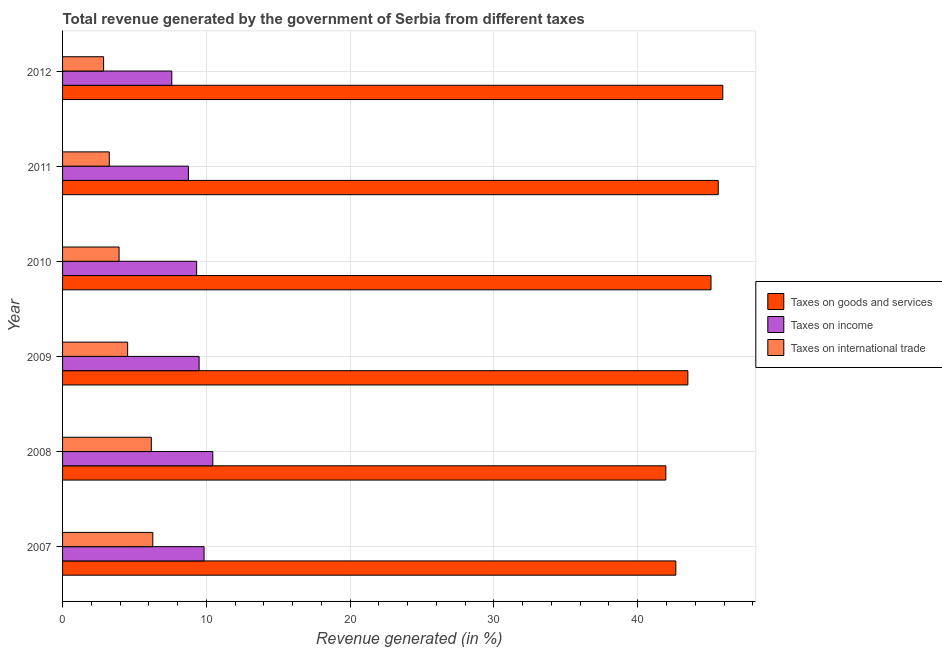How many different coloured bars are there?
Your answer should be very brief. 3. Are the number of bars per tick equal to the number of legend labels?
Offer a terse response. Yes. Are the number of bars on each tick of the Y-axis equal?
Your response must be concise. Yes. How many bars are there on the 2nd tick from the top?
Provide a succinct answer. 3. What is the label of the 3rd group of bars from the top?
Offer a very short reply. 2010. In how many cases, is the number of bars for a given year not equal to the number of legend labels?
Give a very brief answer. 0. What is the percentage of revenue generated by tax on international trade in 2011?
Your answer should be very brief. 3.25. Across all years, what is the maximum percentage of revenue generated by taxes on income?
Your response must be concise. 10.45. Across all years, what is the minimum percentage of revenue generated by taxes on income?
Offer a terse response. 7.6. What is the total percentage of revenue generated by taxes on goods and services in the graph?
Ensure brevity in your answer.  264.69. What is the difference between the percentage of revenue generated by tax on international trade in 2009 and that in 2012?
Give a very brief answer. 1.67. What is the difference between the percentage of revenue generated by tax on international trade in 2007 and the percentage of revenue generated by taxes on goods and services in 2008?
Make the answer very short. -35.68. What is the average percentage of revenue generated by tax on international trade per year?
Make the answer very short. 4.5. In the year 2011, what is the difference between the percentage of revenue generated by taxes on income and percentage of revenue generated by taxes on goods and services?
Make the answer very short. -36.85. In how many years, is the percentage of revenue generated by taxes on income greater than 18 %?
Your response must be concise. 0. What is the ratio of the percentage of revenue generated by taxes on income in 2011 to that in 2012?
Give a very brief answer. 1.15. What is the difference between the highest and the second highest percentage of revenue generated by tax on international trade?
Provide a succinct answer. 0.1. What is the difference between the highest and the lowest percentage of revenue generated by taxes on goods and services?
Your answer should be compact. 3.96. In how many years, is the percentage of revenue generated by taxes on goods and services greater than the average percentage of revenue generated by taxes on goods and services taken over all years?
Your answer should be compact. 3. What does the 3rd bar from the top in 2008 represents?
Your answer should be very brief. Taxes on goods and services. What does the 3rd bar from the bottom in 2008 represents?
Offer a terse response. Taxes on international trade. Are all the bars in the graph horizontal?
Give a very brief answer. Yes. How many years are there in the graph?
Offer a very short reply. 6. Does the graph contain grids?
Offer a terse response. Yes. Where does the legend appear in the graph?
Provide a short and direct response. Center right. How many legend labels are there?
Give a very brief answer. 3. How are the legend labels stacked?
Give a very brief answer. Vertical. What is the title of the graph?
Offer a very short reply. Total revenue generated by the government of Serbia from different taxes. Does "Nuclear sources" appear as one of the legend labels in the graph?
Ensure brevity in your answer.  No. What is the label or title of the X-axis?
Make the answer very short. Revenue generated (in %). What is the label or title of the Y-axis?
Your answer should be compact. Year. What is the Revenue generated (in %) of Taxes on goods and services in 2007?
Your answer should be very brief. 42.65. What is the Revenue generated (in %) in Taxes on income in 2007?
Offer a terse response. 9.84. What is the Revenue generated (in %) of Taxes on international trade in 2007?
Offer a terse response. 6.28. What is the Revenue generated (in %) in Taxes on goods and services in 2008?
Offer a very short reply. 41.95. What is the Revenue generated (in %) in Taxes on income in 2008?
Your answer should be very brief. 10.45. What is the Revenue generated (in %) of Taxes on international trade in 2008?
Make the answer very short. 6.17. What is the Revenue generated (in %) in Taxes on goods and services in 2009?
Your answer should be compact. 43.49. What is the Revenue generated (in %) of Taxes on income in 2009?
Provide a short and direct response. 9.5. What is the Revenue generated (in %) in Taxes on international trade in 2009?
Your response must be concise. 4.53. What is the Revenue generated (in %) of Taxes on goods and services in 2010?
Offer a very short reply. 45.09. What is the Revenue generated (in %) of Taxes on income in 2010?
Provide a short and direct response. 9.32. What is the Revenue generated (in %) of Taxes on international trade in 2010?
Your response must be concise. 3.93. What is the Revenue generated (in %) in Taxes on goods and services in 2011?
Provide a short and direct response. 45.6. What is the Revenue generated (in %) in Taxes on income in 2011?
Make the answer very short. 8.75. What is the Revenue generated (in %) of Taxes on international trade in 2011?
Your answer should be very brief. 3.25. What is the Revenue generated (in %) in Taxes on goods and services in 2012?
Ensure brevity in your answer.  45.91. What is the Revenue generated (in %) in Taxes on income in 2012?
Your response must be concise. 7.6. What is the Revenue generated (in %) in Taxes on international trade in 2012?
Offer a terse response. 2.85. Across all years, what is the maximum Revenue generated (in %) of Taxes on goods and services?
Offer a very short reply. 45.91. Across all years, what is the maximum Revenue generated (in %) of Taxes on income?
Provide a short and direct response. 10.45. Across all years, what is the maximum Revenue generated (in %) of Taxes on international trade?
Your answer should be very brief. 6.28. Across all years, what is the minimum Revenue generated (in %) in Taxes on goods and services?
Your response must be concise. 41.95. Across all years, what is the minimum Revenue generated (in %) in Taxes on income?
Offer a terse response. 7.6. Across all years, what is the minimum Revenue generated (in %) in Taxes on international trade?
Offer a terse response. 2.85. What is the total Revenue generated (in %) in Taxes on goods and services in the graph?
Provide a succinct answer. 264.69. What is the total Revenue generated (in %) of Taxes on income in the graph?
Offer a very short reply. 55.46. What is the total Revenue generated (in %) of Taxes on international trade in the graph?
Offer a terse response. 27.01. What is the difference between the Revenue generated (in %) of Taxes on goods and services in 2007 and that in 2008?
Your response must be concise. 0.69. What is the difference between the Revenue generated (in %) of Taxes on income in 2007 and that in 2008?
Ensure brevity in your answer.  -0.61. What is the difference between the Revenue generated (in %) in Taxes on international trade in 2007 and that in 2008?
Offer a terse response. 0.1. What is the difference between the Revenue generated (in %) in Taxes on goods and services in 2007 and that in 2009?
Make the answer very short. -0.84. What is the difference between the Revenue generated (in %) of Taxes on income in 2007 and that in 2009?
Ensure brevity in your answer.  0.34. What is the difference between the Revenue generated (in %) in Taxes on international trade in 2007 and that in 2009?
Keep it short and to the point. 1.75. What is the difference between the Revenue generated (in %) of Taxes on goods and services in 2007 and that in 2010?
Provide a short and direct response. -2.45. What is the difference between the Revenue generated (in %) of Taxes on income in 2007 and that in 2010?
Offer a terse response. 0.52. What is the difference between the Revenue generated (in %) of Taxes on international trade in 2007 and that in 2010?
Provide a short and direct response. 2.35. What is the difference between the Revenue generated (in %) in Taxes on goods and services in 2007 and that in 2011?
Your response must be concise. -2.95. What is the difference between the Revenue generated (in %) in Taxes on income in 2007 and that in 2011?
Your answer should be very brief. 1.09. What is the difference between the Revenue generated (in %) in Taxes on international trade in 2007 and that in 2011?
Your answer should be compact. 3.03. What is the difference between the Revenue generated (in %) of Taxes on goods and services in 2007 and that in 2012?
Keep it short and to the point. -3.27. What is the difference between the Revenue generated (in %) in Taxes on income in 2007 and that in 2012?
Your answer should be compact. 2.24. What is the difference between the Revenue generated (in %) in Taxes on international trade in 2007 and that in 2012?
Offer a very short reply. 3.42. What is the difference between the Revenue generated (in %) of Taxes on goods and services in 2008 and that in 2009?
Your response must be concise. -1.53. What is the difference between the Revenue generated (in %) of Taxes on international trade in 2008 and that in 2009?
Provide a succinct answer. 1.65. What is the difference between the Revenue generated (in %) of Taxes on goods and services in 2008 and that in 2010?
Ensure brevity in your answer.  -3.14. What is the difference between the Revenue generated (in %) of Taxes on income in 2008 and that in 2010?
Ensure brevity in your answer.  1.12. What is the difference between the Revenue generated (in %) in Taxes on international trade in 2008 and that in 2010?
Your response must be concise. 2.24. What is the difference between the Revenue generated (in %) of Taxes on goods and services in 2008 and that in 2011?
Your answer should be very brief. -3.64. What is the difference between the Revenue generated (in %) in Taxes on income in 2008 and that in 2011?
Make the answer very short. 1.7. What is the difference between the Revenue generated (in %) of Taxes on international trade in 2008 and that in 2011?
Keep it short and to the point. 2.92. What is the difference between the Revenue generated (in %) in Taxes on goods and services in 2008 and that in 2012?
Give a very brief answer. -3.96. What is the difference between the Revenue generated (in %) in Taxes on income in 2008 and that in 2012?
Keep it short and to the point. 2.85. What is the difference between the Revenue generated (in %) of Taxes on international trade in 2008 and that in 2012?
Offer a very short reply. 3.32. What is the difference between the Revenue generated (in %) of Taxes on goods and services in 2009 and that in 2010?
Your answer should be very brief. -1.61. What is the difference between the Revenue generated (in %) of Taxes on income in 2009 and that in 2010?
Provide a succinct answer. 0.17. What is the difference between the Revenue generated (in %) in Taxes on international trade in 2009 and that in 2010?
Offer a terse response. 0.6. What is the difference between the Revenue generated (in %) of Taxes on goods and services in 2009 and that in 2011?
Ensure brevity in your answer.  -2.11. What is the difference between the Revenue generated (in %) of Taxes on income in 2009 and that in 2011?
Ensure brevity in your answer.  0.75. What is the difference between the Revenue generated (in %) in Taxes on international trade in 2009 and that in 2011?
Offer a terse response. 1.28. What is the difference between the Revenue generated (in %) of Taxes on goods and services in 2009 and that in 2012?
Offer a very short reply. -2.43. What is the difference between the Revenue generated (in %) of Taxes on income in 2009 and that in 2012?
Ensure brevity in your answer.  1.9. What is the difference between the Revenue generated (in %) of Taxes on international trade in 2009 and that in 2012?
Your answer should be very brief. 1.67. What is the difference between the Revenue generated (in %) in Taxes on goods and services in 2010 and that in 2011?
Offer a very short reply. -0.5. What is the difference between the Revenue generated (in %) of Taxes on income in 2010 and that in 2011?
Provide a succinct answer. 0.57. What is the difference between the Revenue generated (in %) in Taxes on international trade in 2010 and that in 2011?
Your answer should be compact. 0.68. What is the difference between the Revenue generated (in %) in Taxes on goods and services in 2010 and that in 2012?
Keep it short and to the point. -0.82. What is the difference between the Revenue generated (in %) of Taxes on income in 2010 and that in 2012?
Offer a terse response. 1.73. What is the difference between the Revenue generated (in %) in Taxes on international trade in 2010 and that in 2012?
Ensure brevity in your answer.  1.08. What is the difference between the Revenue generated (in %) of Taxes on goods and services in 2011 and that in 2012?
Your answer should be compact. -0.32. What is the difference between the Revenue generated (in %) in Taxes on income in 2011 and that in 2012?
Ensure brevity in your answer.  1.15. What is the difference between the Revenue generated (in %) of Taxes on international trade in 2011 and that in 2012?
Give a very brief answer. 0.4. What is the difference between the Revenue generated (in %) in Taxes on goods and services in 2007 and the Revenue generated (in %) in Taxes on income in 2008?
Provide a succinct answer. 32.2. What is the difference between the Revenue generated (in %) of Taxes on goods and services in 2007 and the Revenue generated (in %) of Taxes on international trade in 2008?
Provide a short and direct response. 36.48. What is the difference between the Revenue generated (in %) in Taxes on income in 2007 and the Revenue generated (in %) in Taxes on international trade in 2008?
Offer a terse response. 3.67. What is the difference between the Revenue generated (in %) of Taxes on goods and services in 2007 and the Revenue generated (in %) of Taxes on income in 2009?
Make the answer very short. 33.15. What is the difference between the Revenue generated (in %) of Taxes on goods and services in 2007 and the Revenue generated (in %) of Taxes on international trade in 2009?
Your answer should be compact. 38.12. What is the difference between the Revenue generated (in %) in Taxes on income in 2007 and the Revenue generated (in %) in Taxes on international trade in 2009?
Provide a short and direct response. 5.31. What is the difference between the Revenue generated (in %) of Taxes on goods and services in 2007 and the Revenue generated (in %) of Taxes on income in 2010?
Provide a succinct answer. 33.32. What is the difference between the Revenue generated (in %) of Taxes on goods and services in 2007 and the Revenue generated (in %) of Taxes on international trade in 2010?
Offer a very short reply. 38.72. What is the difference between the Revenue generated (in %) in Taxes on income in 2007 and the Revenue generated (in %) in Taxes on international trade in 2010?
Ensure brevity in your answer.  5.91. What is the difference between the Revenue generated (in %) of Taxes on goods and services in 2007 and the Revenue generated (in %) of Taxes on income in 2011?
Your response must be concise. 33.9. What is the difference between the Revenue generated (in %) in Taxes on goods and services in 2007 and the Revenue generated (in %) in Taxes on international trade in 2011?
Your answer should be compact. 39.4. What is the difference between the Revenue generated (in %) of Taxes on income in 2007 and the Revenue generated (in %) of Taxes on international trade in 2011?
Offer a terse response. 6.59. What is the difference between the Revenue generated (in %) of Taxes on goods and services in 2007 and the Revenue generated (in %) of Taxes on income in 2012?
Your answer should be compact. 35.05. What is the difference between the Revenue generated (in %) of Taxes on goods and services in 2007 and the Revenue generated (in %) of Taxes on international trade in 2012?
Ensure brevity in your answer.  39.79. What is the difference between the Revenue generated (in %) of Taxes on income in 2007 and the Revenue generated (in %) of Taxes on international trade in 2012?
Give a very brief answer. 6.99. What is the difference between the Revenue generated (in %) in Taxes on goods and services in 2008 and the Revenue generated (in %) in Taxes on income in 2009?
Give a very brief answer. 32.46. What is the difference between the Revenue generated (in %) in Taxes on goods and services in 2008 and the Revenue generated (in %) in Taxes on international trade in 2009?
Offer a very short reply. 37.43. What is the difference between the Revenue generated (in %) of Taxes on income in 2008 and the Revenue generated (in %) of Taxes on international trade in 2009?
Offer a terse response. 5.92. What is the difference between the Revenue generated (in %) in Taxes on goods and services in 2008 and the Revenue generated (in %) in Taxes on income in 2010?
Keep it short and to the point. 32.63. What is the difference between the Revenue generated (in %) of Taxes on goods and services in 2008 and the Revenue generated (in %) of Taxes on international trade in 2010?
Your response must be concise. 38.02. What is the difference between the Revenue generated (in %) in Taxes on income in 2008 and the Revenue generated (in %) in Taxes on international trade in 2010?
Provide a short and direct response. 6.52. What is the difference between the Revenue generated (in %) in Taxes on goods and services in 2008 and the Revenue generated (in %) in Taxes on income in 2011?
Your answer should be compact. 33.2. What is the difference between the Revenue generated (in %) in Taxes on goods and services in 2008 and the Revenue generated (in %) in Taxes on international trade in 2011?
Your answer should be very brief. 38.7. What is the difference between the Revenue generated (in %) of Taxes on income in 2008 and the Revenue generated (in %) of Taxes on international trade in 2011?
Your answer should be very brief. 7.2. What is the difference between the Revenue generated (in %) in Taxes on goods and services in 2008 and the Revenue generated (in %) in Taxes on income in 2012?
Provide a succinct answer. 34.36. What is the difference between the Revenue generated (in %) of Taxes on goods and services in 2008 and the Revenue generated (in %) of Taxes on international trade in 2012?
Provide a short and direct response. 39.1. What is the difference between the Revenue generated (in %) of Taxes on income in 2008 and the Revenue generated (in %) of Taxes on international trade in 2012?
Your answer should be very brief. 7.59. What is the difference between the Revenue generated (in %) of Taxes on goods and services in 2009 and the Revenue generated (in %) of Taxes on income in 2010?
Your answer should be very brief. 34.16. What is the difference between the Revenue generated (in %) in Taxes on goods and services in 2009 and the Revenue generated (in %) in Taxes on international trade in 2010?
Offer a very short reply. 39.55. What is the difference between the Revenue generated (in %) in Taxes on income in 2009 and the Revenue generated (in %) in Taxes on international trade in 2010?
Keep it short and to the point. 5.57. What is the difference between the Revenue generated (in %) of Taxes on goods and services in 2009 and the Revenue generated (in %) of Taxes on income in 2011?
Offer a terse response. 34.73. What is the difference between the Revenue generated (in %) in Taxes on goods and services in 2009 and the Revenue generated (in %) in Taxes on international trade in 2011?
Your response must be concise. 40.24. What is the difference between the Revenue generated (in %) of Taxes on income in 2009 and the Revenue generated (in %) of Taxes on international trade in 2011?
Your answer should be compact. 6.25. What is the difference between the Revenue generated (in %) of Taxes on goods and services in 2009 and the Revenue generated (in %) of Taxes on income in 2012?
Your answer should be very brief. 35.89. What is the difference between the Revenue generated (in %) in Taxes on goods and services in 2009 and the Revenue generated (in %) in Taxes on international trade in 2012?
Your answer should be very brief. 40.63. What is the difference between the Revenue generated (in %) in Taxes on income in 2009 and the Revenue generated (in %) in Taxes on international trade in 2012?
Your answer should be compact. 6.64. What is the difference between the Revenue generated (in %) of Taxes on goods and services in 2010 and the Revenue generated (in %) of Taxes on income in 2011?
Keep it short and to the point. 36.34. What is the difference between the Revenue generated (in %) in Taxes on goods and services in 2010 and the Revenue generated (in %) in Taxes on international trade in 2011?
Ensure brevity in your answer.  41.85. What is the difference between the Revenue generated (in %) of Taxes on income in 2010 and the Revenue generated (in %) of Taxes on international trade in 2011?
Keep it short and to the point. 6.08. What is the difference between the Revenue generated (in %) in Taxes on goods and services in 2010 and the Revenue generated (in %) in Taxes on income in 2012?
Your answer should be very brief. 37.5. What is the difference between the Revenue generated (in %) of Taxes on goods and services in 2010 and the Revenue generated (in %) of Taxes on international trade in 2012?
Offer a terse response. 42.24. What is the difference between the Revenue generated (in %) in Taxes on income in 2010 and the Revenue generated (in %) in Taxes on international trade in 2012?
Keep it short and to the point. 6.47. What is the difference between the Revenue generated (in %) of Taxes on goods and services in 2011 and the Revenue generated (in %) of Taxes on income in 2012?
Your answer should be compact. 38. What is the difference between the Revenue generated (in %) in Taxes on goods and services in 2011 and the Revenue generated (in %) in Taxes on international trade in 2012?
Ensure brevity in your answer.  42.74. What is the difference between the Revenue generated (in %) of Taxes on income in 2011 and the Revenue generated (in %) of Taxes on international trade in 2012?
Your answer should be compact. 5.9. What is the average Revenue generated (in %) of Taxes on goods and services per year?
Provide a short and direct response. 44.12. What is the average Revenue generated (in %) of Taxes on income per year?
Your answer should be very brief. 9.24. What is the average Revenue generated (in %) of Taxes on international trade per year?
Your answer should be very brief. 4.5. In the year 2007, what is the difference between the Revenue generated (in %) in Taxes on goods and services and Revenue generated (in %) in Taxes on income?
Keep it short and to the point. 32.81. In the year 2007, what is the difference between the Revenue generated (in %) in Taxes on goods and services and Revenue generated (in %) in Taxes on international trade?
Make the answer very short. 36.37. In the year 2007, what is the difference between the Revenue generated (in %) in Taxes on income and Revenue generated (in %) in Taxes on international trade?
Ensure brevity in your answer.  3.56. In the year 2008, what is the difference between the Revenue generated (in %) of Taxes on goods and services and Revenue generated (in %) of Taxes on income?
Your response must be concise. 31.51. In the year 2008, what is the difference between the Revenue generated (in %) of Taxes on goods and services and Revenue generated (in %) of Taxes on international trade?
Your response must be concise. 35.78. In the year 2008, what is the difference between the Revenue generated (in %) in Taxes on income and Revenue generated (in %) in Taxes on international trade?
Offer a very short reply. 4.28. In the year 2009, what is the difference between the Revenue generated (in %) in Taxes on goods and services and Revenue generated (in %) in Taxes on income?
Your response must be concise. 33.99. In the year 2009, what is the difference between the Revenue generated (in %) of Taxes on goods and services and Revenue generated (in %) of Taxes on international trade?
Your answer should be very brief. 38.96. In the year 2009, what is the difference between the Revenue generated (in %) in Taxes on income and Revenue generated (in %) in Taxes on international trade?
Give a very brief answer. 4.97. In the year 2010, what is the difference between the Revenue generated (in %) in Taxes on goods and services and Revenue generated (in %) in Taxes on income?
Provide a succinct answer. 35.77. In the year 2010, what is the difference between the Revenue generated (in %) of Taxes on goods and services and Revenue generated (in %) of Taxes on international trade?
Provide a short and direct response. 41.16. In the year 2010, what is the difference between the Revenue generated (in %) in Taxes on income and Revenue generated (in %) in Taxes on international trade?
Keep it short and to the point. 5.39. In the year 2011, what is the difference between the Revenue generated (in %) in Taxes on goods and services and Revenue generated (in %) in Taxes on income?
Your answer should be compact. 36.85. In the year 2011, what is the difference between the Revenue generated (in %) in Taxes on goods and services and Revenue generated (in %) in Taxes on international trade?
Make the answer very short. 42.35. In the year 2011, what is the difference between the Revenue generated (in %) of Taxes on income and Revenue generated (in %) of Taxes on international trade?
Offer a very short reply. 5.5. In the year 2012, what is the difference between the Revenue generated (in %) of Taxes on goods and services and Revenue generated (in %) of Taxes on income?
Keep it short and to the point. 38.32. In the year 2012, what is the difference between the Revenue generated (in %) of Taxes on goods and services and Revenue generated (in %) of Taxes on international trade?
Offer a terse response. 43.06. In the year 2012, what is the difference between the Revenue generated (in %) in Taxes on income and Revenue generated (in %) in Taxes on international trade?
Ensure brevity in your answer.  4.74. What is the ratio of the Revenue generated (in %) in Taxes on goods and services in 2007 to that in 2008?
Offer a very short reply. 1.02. What is the ratio of the Revenue generated (in %) in Taxes on income in 2007 to that in 2008?
Provide a succinct answer. 0.94. What is the ratio of the Revenue generated (in %) in Taxes on international trade in 2007 to that in 2008?
Offer a very short reply. 1.02. What is the ratio of the Revenue generated (in %) in Taxes on goods and services in 2007 to that in 2009?
Make the answer very short. 0.98. What is the ratio of the Revenue generated (in %) in Taxes on income in 2007 to that in 2009?
Give a very brief answer. 1.04. What is the ratio of the Revenue generated (in %) in Taxes on international trade in 2007 to that in 2009?
Keep it short and to the point. 1.39. What is the ratio of the Revenue generated (in %) of Taxes on goods and services in 2007 to that in 2010?
Keep it short and to the point. 0.95. What is the ratio of the Revenue generated (in %) in Taxes on income in 2007 to that in 2010?
Provide a short and direct response. 1.06. What is the ratio of the Revenue generated (in %) in Taxes on international trade in 2007 to that in 2010?
Give a very brief answer. 1.6. What is the ratio of the Revenue generated (in %) of Taxes on goods and services in 2007 to that in 2011?
Make the answer very short. 0.94. What is the ratio of the Revenue generated (in %) of Taxes on income in 2007 to that in 2011?
Your answer should be very brief. 1.12. What is the ratio of the Revenue generated (in %) in Taxes on international trade in 2007 to that in 2011?
Give a very brief answer. 1.93. What is the ratio of the Revenue generated (in %) in Taxes on goods and services in 2007 to that in 2012?
Make the answer very short. 0.93. What is the ratio of the Revenue generated (in %) of Taxes on income in 2007 to that in 2012?
Offer a very short reply. 1.3. What is the ratio of the Revenue generated (in %) in Taxes on international trade in 2007 to that in 2012?
Keep it short and to the point. 2.2. What is the ratio of the Revenue generated (in %) in Taxes on goods and services in 2008 to that in 2009?
Ensure brevity in your answer.  0.96. What is the ratio of the Revenue generated (in %) in Taxes on income in 2008 to that in 2009?
Provide a succinct answer. 1.1. What is the ratio of the Revenue generated (in %) in Taxes on international trade in 2008 to that in 2009?
Offer a terse response. 1.36. What is the ratio of the Revenue generated (in %) in Taxes on goods and services in 2008 to that in 2010?
Provide a succinct answer. 0.93. What is the ratio of the Revenue generated (in %) of Taxes on income in 2008 to that in 2010?
Your response must be concise. 1.12. What is the ratio of the Revenue generated (in %) in Taxes on international trade in 2008 to that in 2010?
Offer a very short reply. 1.57. What is the ratio of the Revenue generated (in %) in Taxes on goods and services in 2008 to that in 2011?
Give a very brief answer. 0.92. What is the ratio of the Revenue generated (in %) of Taxes on income in 2008 to that in 2011?
Your response must be concise. 1.19. What is the ratio of the Revenue generated (in %) in Taxes on international trade in 2008 to that in 2011?
Keep it short and to the point. 1.9. What is the ratio of the Revenue generated (in %) in Taxes on goods and services in 2008 to that in 2012?
Offer a terse response. 0.91. What is the ratio of the Revenue generated (in %) of Taxes on income in 2008 to that in 2012?
Give a very brief answer. 1.38. What is the ratio of the Revenue generated (in %) of Taxes on international trade in 2008 to that in 2012?
Offer a terse response. 2.16. What is the ratio of the Revenue generated (in %) of Taxes on goods and services in 2009 to that in 2010?
Give a very brief answer. 0.96. What is the ratio of the Revenue generated (in %) of Taxes on income in 2009 to that in 2010?
Keep it short and to the point. 1.02. What is the ratio of the Revenue generated (in %) of Taxes on international trade in 2009 to that in 2010?
Keep it short and to the point. 1.15. What is the ratio of the Revenue generated (in %) in Taxes on goods and services in 2009 to that in 2011?
Provide a succinct answer. 0.95. What is the ratio of the Revenue generated (in %) of Taxes on income in 2009 to that in 2011?
Provide a succinct answer. 1.09. What is the ratio of the Revenue generated (in %) of Taxes on international trade in 2009 to that in 2011?
Provide a succinct answer. 1.39. What is the ratio of the Revenue generated (in %) in Taxes on goods and services in 2009 to that in 2012?
Your answer should be very brief. 0.95. What is the ratio of the Revenue generated (in %) in Taxes on income in 2009 to that in 2012?
Your response must be concise. 1.25. What is the ratio of the Revenue generated (in %) in Taxes on international trade in 2009 to that in 2012?
Your answer should be very brief. 1.59. What is the ratio of the Revenue generated (in %) of Taxes on goods and services in 2010 to that in 2011?
Your answer should be very brief. 0.99. What is the ratio of the Revenue generated (in %) in Taxes on income in 2010 to that in 2011?
Offer a terse response. 1.07. What is the ratio of the Revenue generated (in %) in Taxes on international trade in 2010 to that in 2011?
Keep it short and to the point. 1.21. What is the ratio of the Revenue generated (in %) in Taxes on goods and services in 2010 to that in 2012?
Your answer should be very brief. 0.98. What is the ratio of the Revenue generated (in %) in Taxes on income in 2010 to that in 2012?
Offer a terse response. 1.23. What is the ratio of the Revenue generated (in %) in Taxes on international trade in 2010 to that in 2012?
Your response must be concise. 1.38. What is the ratio of the Revenue generated (in %) in Taxes on income in 2011 to that in 2012?
Your answer should be compact. 1.15. What is the ratio of the Revenue generated (in %) in Taxes on international trade in 2011 to that in 2012?
Your response must be concise. 1.14. What is the difference between the highest and the second highest Revenue generated (in %) in Taxes on goods and services?
Give a very brief answer. 0.32. What is the difference between the highest and the second highest Revenue generated (in %) of Taxes on income?
Offer a terse response. 0.61. What is the difference between the highest and the second highest Revenue generated (in %) in Taxes on international trade?
Provide a succinct answer. 0.1. What is the difference between the highest and the lowest Revenue generated (in %) in Taxes on goods and services?
Keep it short and to the point. 3.96. What is the difference between the highest and the lowest Revenue generated (in %) in Taxes on income?
Your answer should be compact. 2.85. What is the difference between the highest and the lowest Revenue generated (in %) of Taxes on international trade?
Offer a terse response. 3.42. 